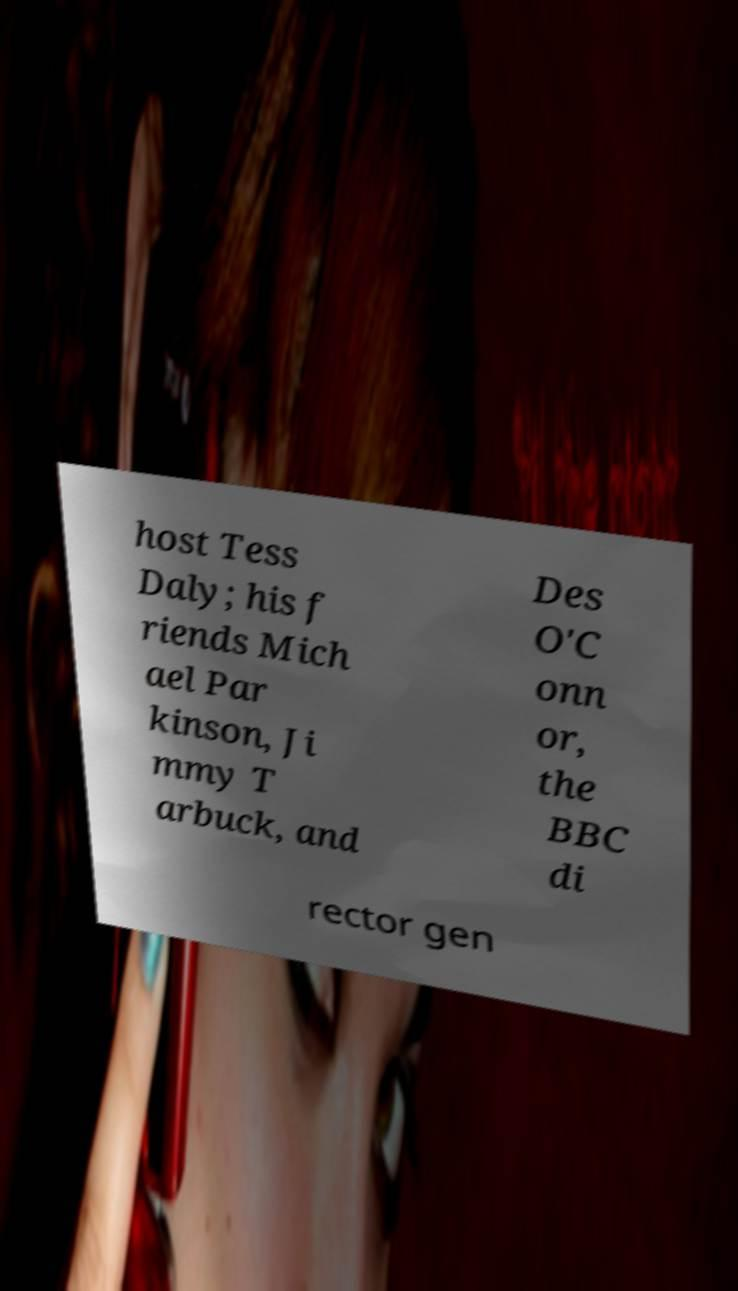Can you accurately transcribe the text from the provided image for me? host Tess Daly; his f riends Mich ael Par kinson, Ji mmy T arbuck, and Des O'C onn or, the BBC di rector gen 